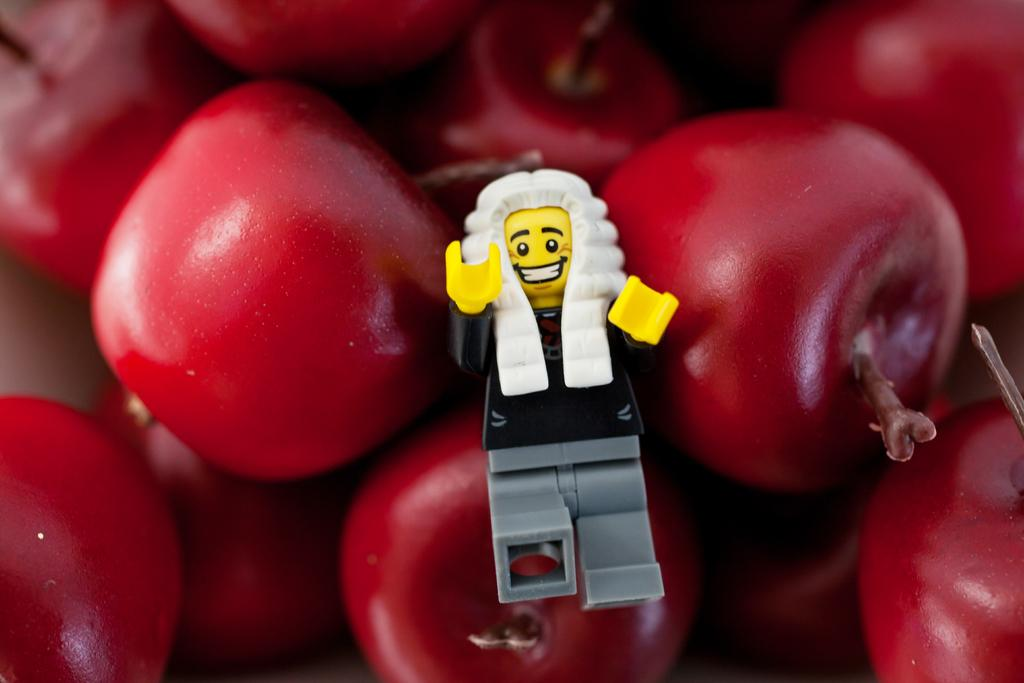Who is present in the image? There is a person in the image. What is the person holding? The person is holding a camera. What can be seen in the background of the image? There is a building in the background of the image. Is there any quicksand visible in the image? No, there is no quicksand present in the image. What type of door can be seen in the image? There is no door present in the image; it features a person holding a camera and a building in the background. 